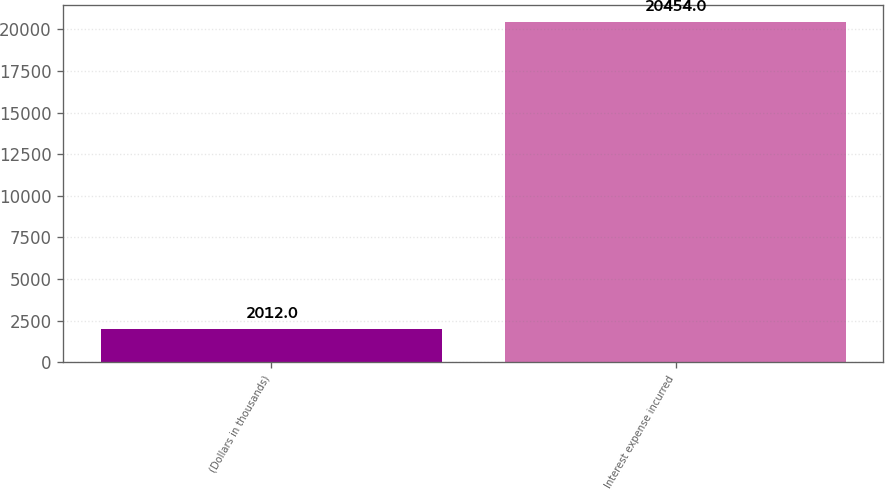<chart> <loc_0><loc_0><loc_500><loc_500><bar_chart><fcel>(Dollars in thousands)<fcel>Interest expense incurred<nl><fcel>2012<fcel>20454<nl></chart> 